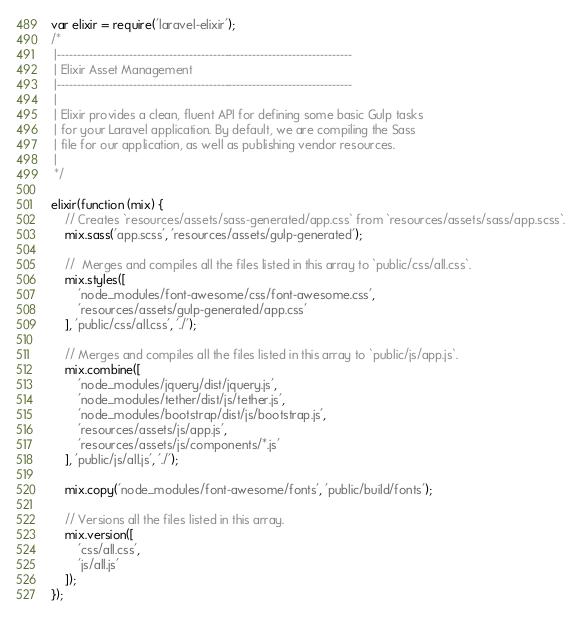Convert code to text. <code><loc_0><loc_0><loc_500><loc_500><_JavaScript_>var elixir = require('laravel-elixir');
/*
 |--------------------------------------------------------------------------
 | Elixir Asset Management
 |--------------------------------------------------------------------------
 |
 | Elixir provides a clean, fluent API for defining some basic Gulp tasks
 | for your Laravel application. By default, we are compiling the Sass
 | file for our application, as well as publishing vendor resources.
 |
 */

elixir(function (mix) {
    // Creates `resources/assets/sass-generated/app.css` from `resources/assets/sass/app.scss`.
    mix.sass('app.scss', 'resources/assets/gulp-generated');

    //  Merges and compiles all the files listed in this array to `public/css/all.css`.
    mix.styles([
        'node_modules/font-awesome/css/font-awesome.css',
        'resources/assets/gulp-generated/app.css'
    ], 'public/css/all.css', './');

    // Merges and compiles all the files listed in this array to `public/js/app.js`.
    mix.combine([
        'node_modules/jquery/dist/jquery.js',
        'node_modules/tether/dist/js/tether.js',
        'node_modules/bootstrap/dist/js/bootstrap.js',
        'resources/assets/js/app.js',
        'resources/assets/js/components/*.js'
    ], 'public/js/all.js', './');

    mix.copy('node_modules/font-awesome/fonts', 'public/build/fonts');

    // Versions all the files listed in this array.
    mix.version([
        'css/all.css',
        'js/all.js'
    ]);
});
</code> 